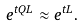<formula> <loc_0><loc_0><loc_500><loc_500>e ^ { t Q L } \approx e ^ { t L } .</formula> 